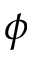Convert formula to latex. <formula><loc_0><loc_0><loc_500><loc_500>\phi</formula> 